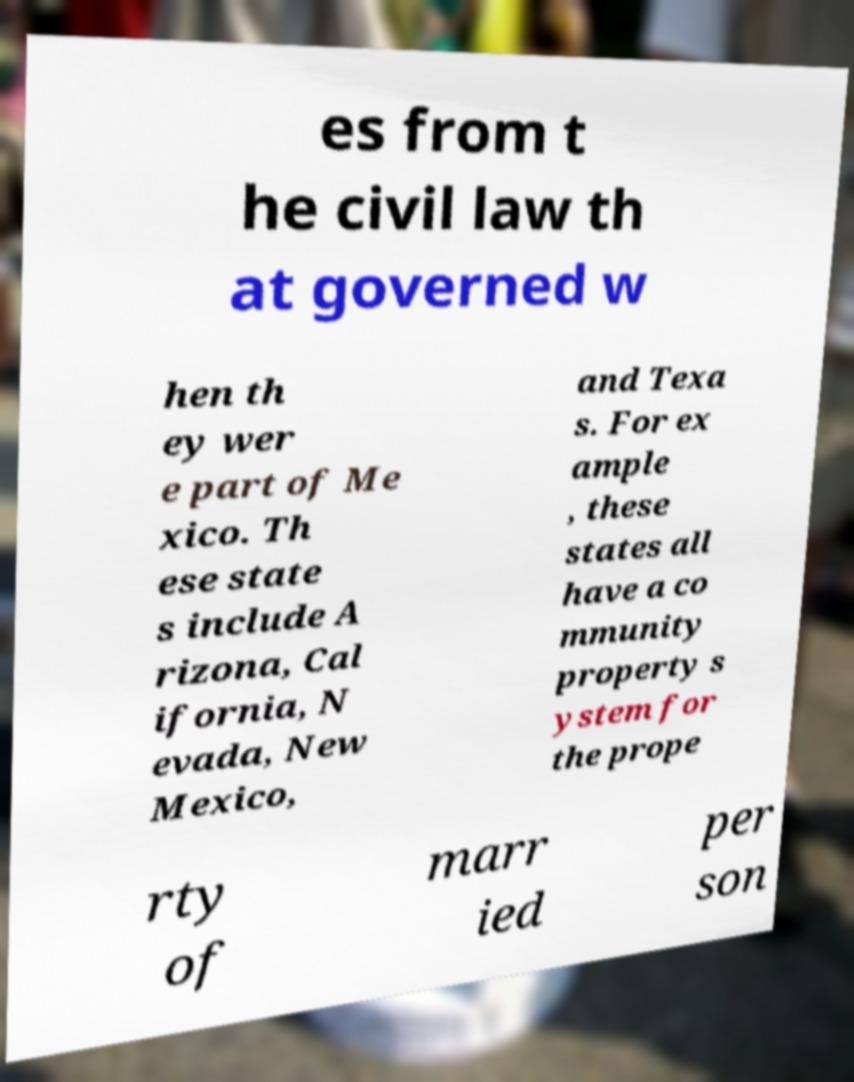There's text embedded in this image that I need extracted. Can you transcribe it verbatim? es from t he civil law th at governed w hen th ey wer e part of Me xico. Th ese state s include A rizona, Cal ifornia, N evada, New Mexico, and Texa s. For ex ample , these states all have a co mmunity property s ystem for the prope rty of marr ied per son 